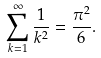<formula> <loc_0><loc_0><loc_500><loc_500>\sum _ { k = 1 } ^ { \infty } \frac { 1 } { k ^ { 2 } } = \frac { \pi ^ { 2 } } { 6 } .</formula> 